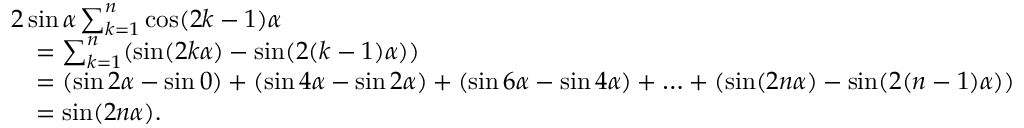<formula> <loc_0><loc_0><loc_500><loc_500>{ \begin{array} { r l } & { 2 \sin \alpha \sum _ { k = 1 } ^ { n } \cos ( 2 k - 1 ) \alpha } \\ & { \quad = \sum _ { k = 1 } ^ { n } ( \sin ( 2 k \alpha ) - \sin ( 2 ( k - 1 ) \alpha ) ) } \\ & { \quad = ( \sin 2 \alpha - \sin 0 ) + ( \sin 4 \alpha - \sin 2 \alpha ) + ( \sin 6 \alpha - \sin 4 \alpha ) + \dots + ( \sin ( 2 n \alpha ) - \sin ( 2 ( n - 1 ) \alpha ) ) } \\ & { \quad = \sin ( 2 n \alpha ) . } \end{array} }</formula> 